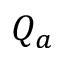<formula> <loc_0><loc_0><loc_500><loc_500>Q _ { a }</formula> 